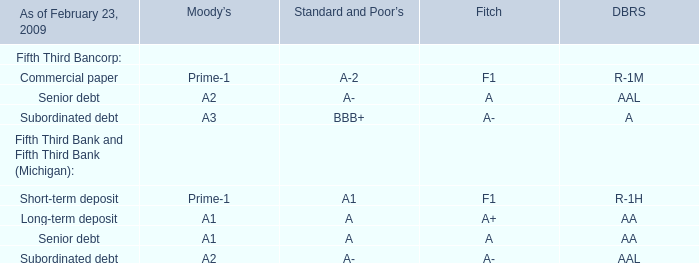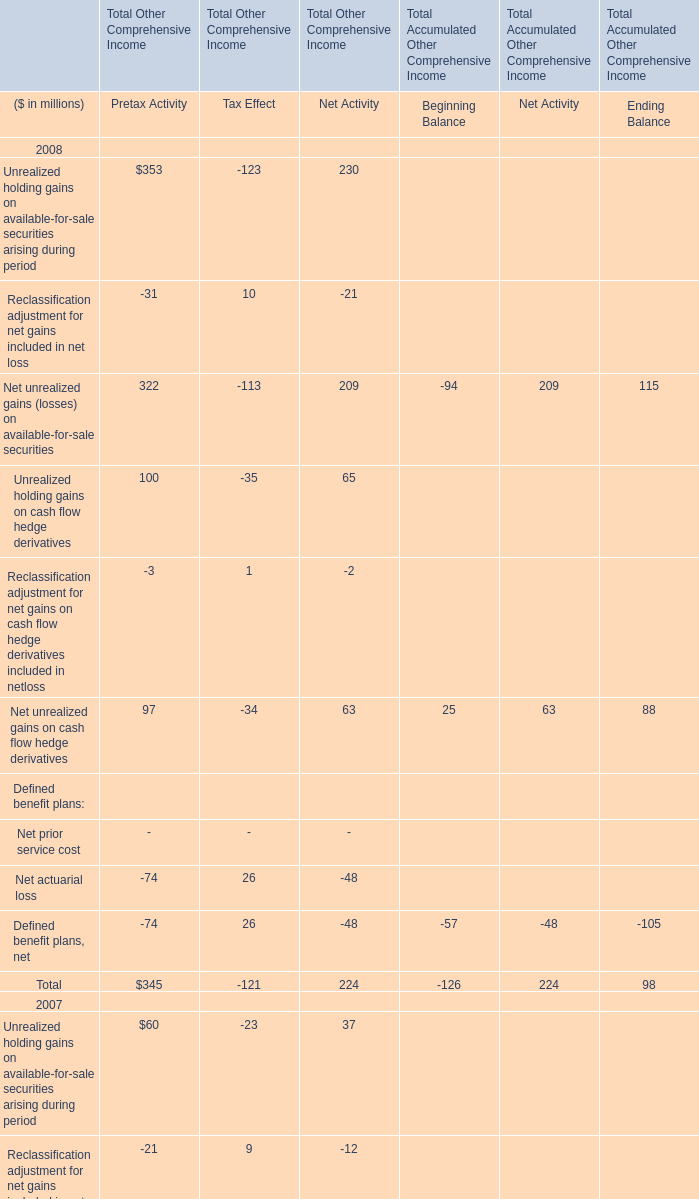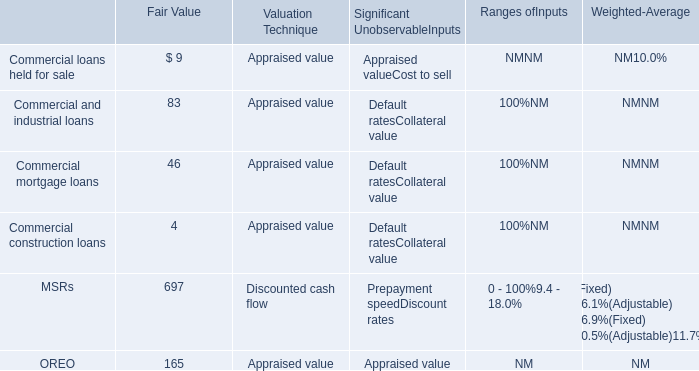during 2013 , what were total losses in millions for charge-offs on new oreo properties and negative fair value adjustments on existing oreo properties? 
Computations: (19 + 26)
Answer: 45.0. 